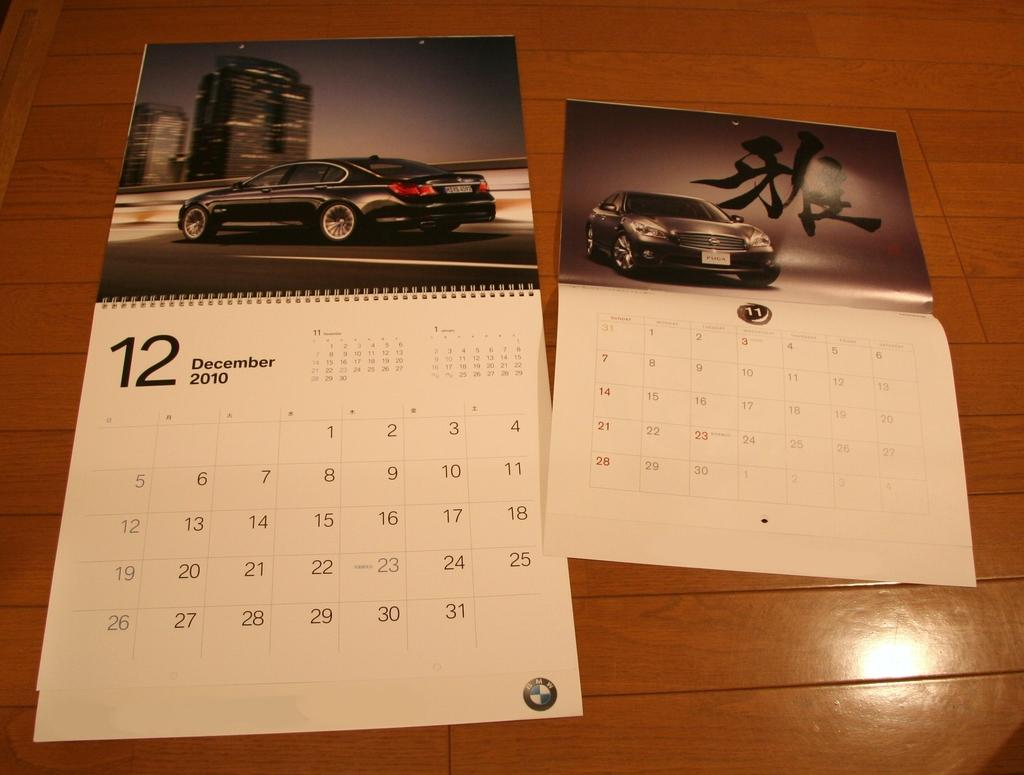What type of items can be seen in the image? There are calendars in the image. Where are the calendars located? The calendars are on a wooden object. What type of quiver is present in the image? There is no quiver present in the image; it only features calendars on a wooden object. 